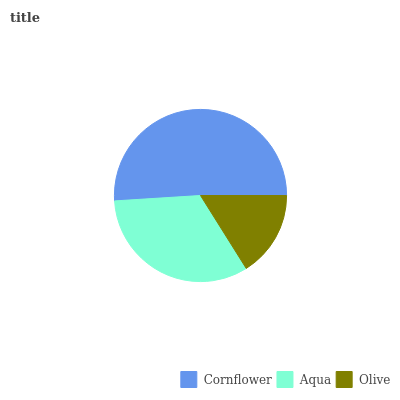Is Olive the minimum?
Answer yes or no. Yes. Is Cornflower the maximum?
Answer yes or no. Yes. Is Aqua the minimum?
Answer yes or no. No. Is Aqua the maximum?
Answer yes or no. No. Is Cornflower greater than Aqua?
Answer yes or no. Yes. Is Aqua less than Cornflower?
Answer yes or no. Yes. Is Aqua greater than Cornflower?
Answer yes or no. No. Is Cornflower less than Aqua?
Answer yes or no. No. Is Aqua the high median?
Answer yes or no. Yes. Is Aqua the low median?
Answer yes or no. Yes. Is Cornflower the high median?
Answer yes or no. No. Is Olive the low median?
Answer yes or no. No. 